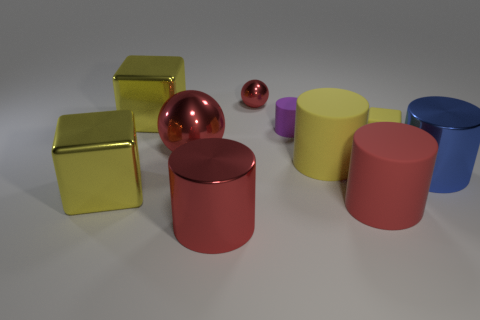Subtract all balls. How many objects are left? 8 Subtract all yellow rubber objects. Subtract all yellow cylinders. How many objects are left? 7 Add 1 big blocks. How many big blocks are left? 3 Add 5 tiny yellow rubber things. How many tiny yellow rubber things exist? 6 Subtract 1 red cylinders. How many objects are left? 9 